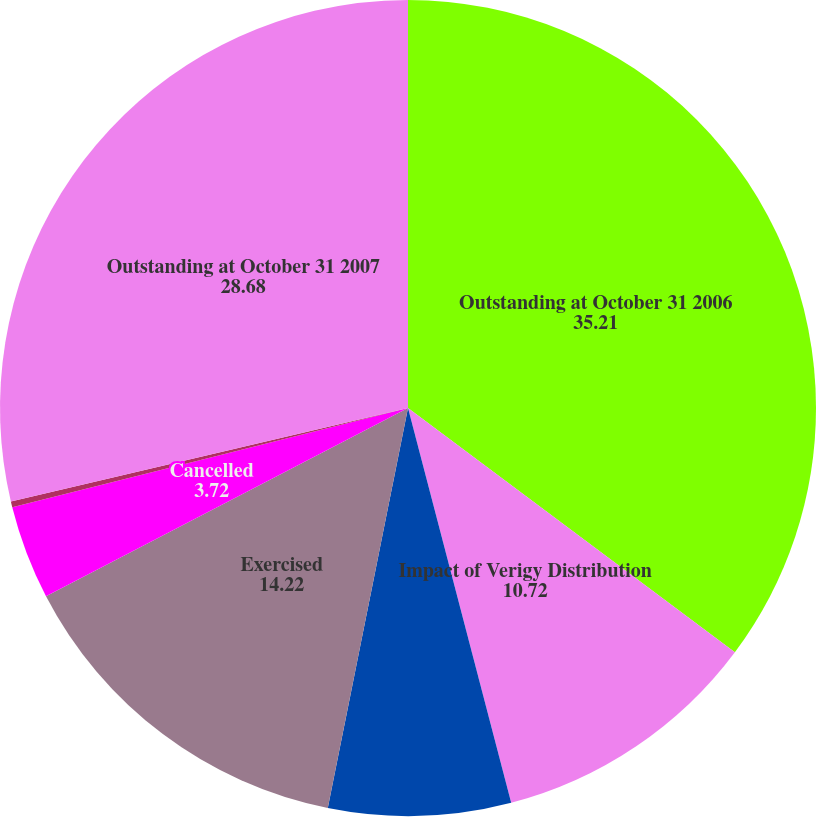Convert chart to OTSL. <chart><loc_0><loc_0><loc_500><loc_500><pie_chart><fcel>Outstanding at October 31 2006<fcel>Impact of Verigy Distribution<fcel>Granted<fcel>Exercised<fcel>Cancelled<fcel>Plan Shares Expired<fcel>Outstanding at October 31 2007<nl><fcel>35.21%<fcel>10.72%<fcel>7.22%<fcel>14.22%<fcel>3.72%<fcel>0.23%<fcel>28.68%<nl></chart> 